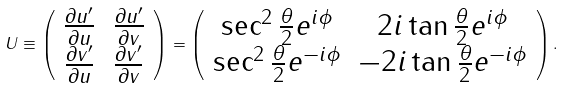<formula> <loc_0><loc_0><loc_500><loc_500>U \equiv \left ( \begin{array} { c c } \frac { \partial u ^ { \prime } } { \partial u } & \frac { \partial u ^ { \prime } } { \partial v } \\ \frac { \partial v ^ { \prime } } { \partial u } & \frac { \partial v ^ { \prime } } { \partial v } \end{array} \right ) = \left ( \begin{array} { c c } \sec ^ { 2 } \frac { \theta } { 2 } e ^ { i \phi } & 2 i \tan \frac { \theta } { 2 } e ^ { i \phi } \\ \sec ^ { 2 } \frac { \theta } { 2 } e ^ { - i \phi } & - 2 i \tan \frac { \theta } { 2 } e ^ { - i \phi } \end{array} \right ) .</formula> 